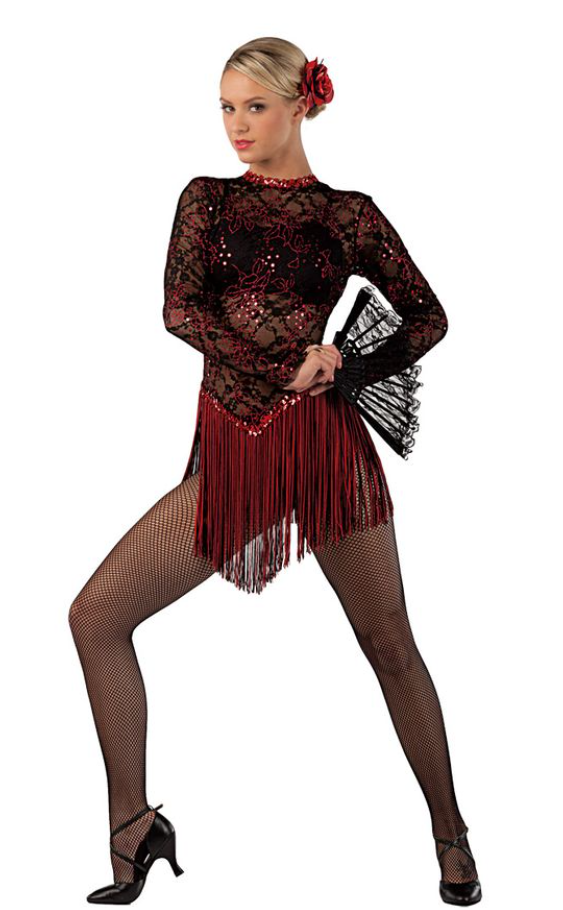Write a poem about this image A dancer in a red dress
With a fan in her hand
Flamenco is the name of the dance
And she's doing it grand

She moves with grace and passion
Her feet tapping the floor
Her castanets clicking
And her skirt swirling

She is a vision of beauty
And strength
And her dance is a joy to behold
She is a true artist

And we are lucky to have her 